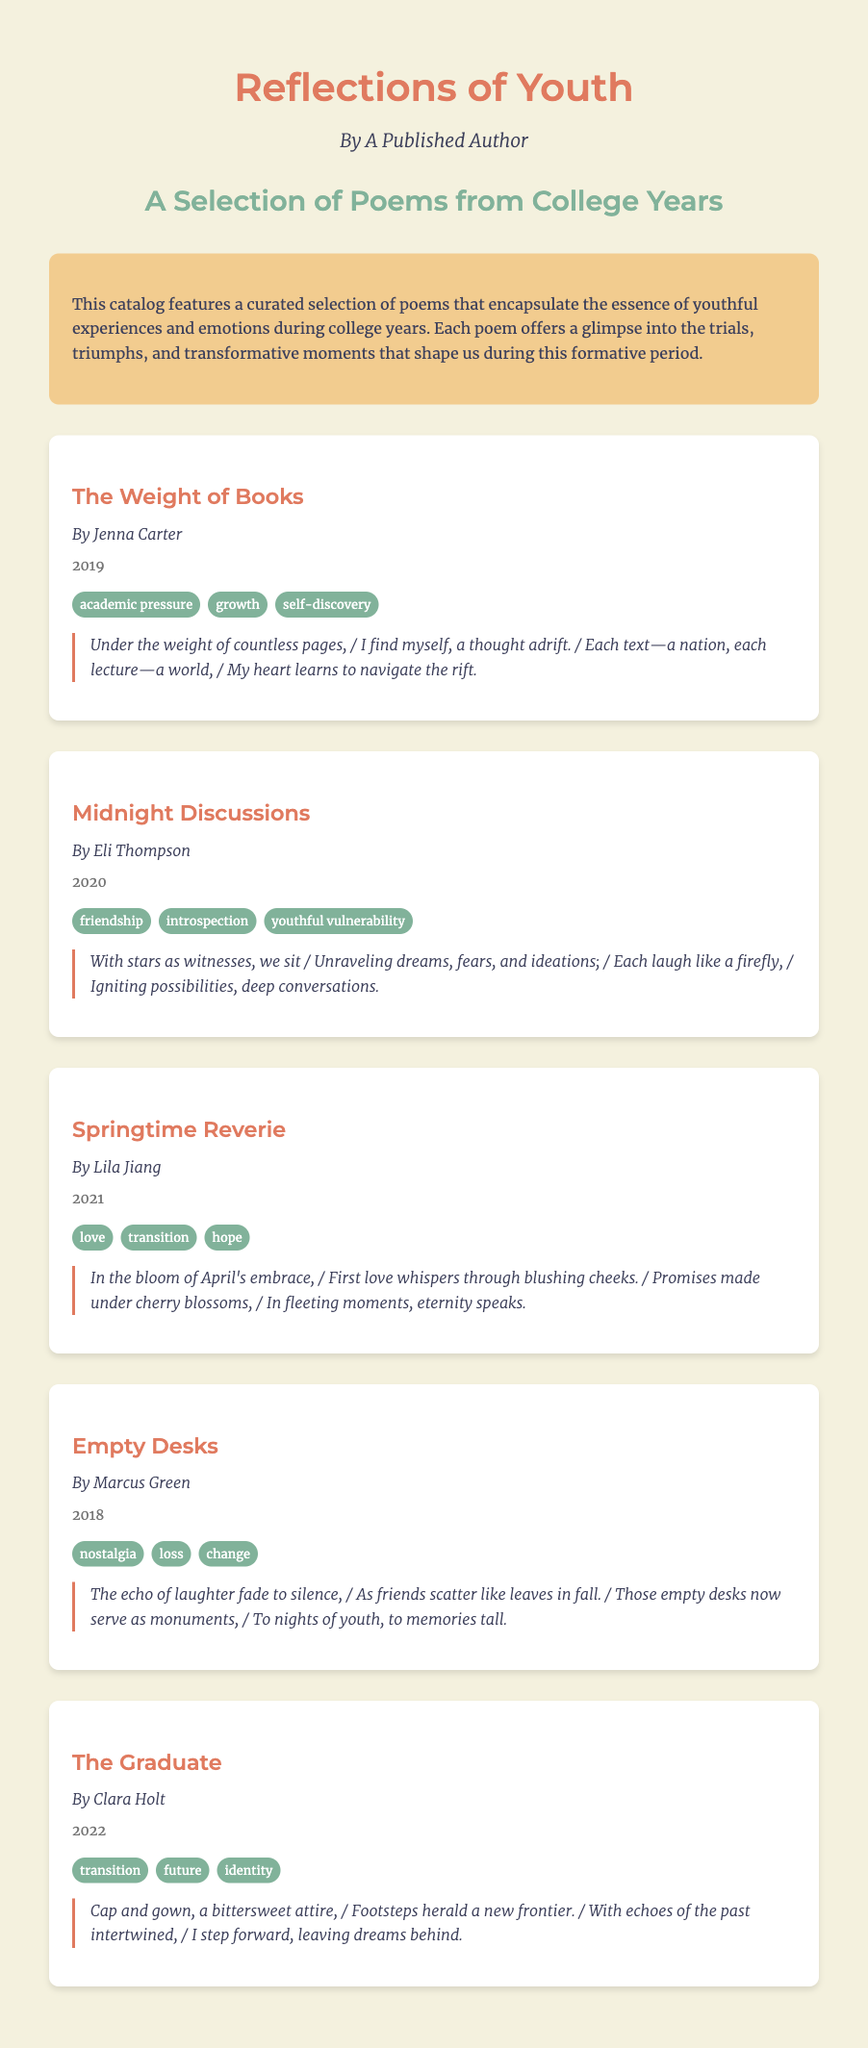What is the title of the catalog? The title of the catalog is found at the top of the document, reflecting its theme.
Answer: Reflections of Youth Who is the author of the catalog? The author is specified in the introductory section of the document.
Answer: A Published Author What year was the poem "The Weight of Books" published? The year is listed under the poem title, indicating its publication date.
Answer: 2019 Which theme is associated with "Midnight Discussions"? Each poem has a set of themes listed beneath its details, providing insight into its content.
Answer: friendship How many poems are featured in the catalog? The total number of poems can be counted in the poems section of the document.
Answer: 5 What is the theme of the poem "The Graduate"? The themes associated with this poem are listed below the title and author.
Answer: transition, future, identity Who wrote the poem "Springtime Reverie"? The author is indicated directly beneath the poem's title.
Answer: Lila Jiang What significant emotion is conveyed in "Empty Desks"? The themes listed provide insight into the emotions addressed in the poem.
Answer: nostalgia What event does the poem "The Graduate" represent? The content of the poem is summarised through its title and themes, hinting at life events.
Answer: graduation 